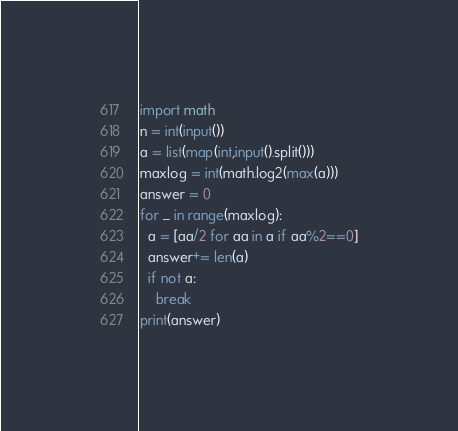Convert code to text. <code><loc_0><loc_0><loc_500><loc_500><_Python_>import math
n = int(input())
a = list(map(int,input().split()))
maxlog = int(math.log2(max(a)))
answer = 0
for _ in range(maxlog):
  a = [aa/2 for aa in a if aa%2==0]
  answer+= len(a)
  if not a:
    break
print(answer)</code> 